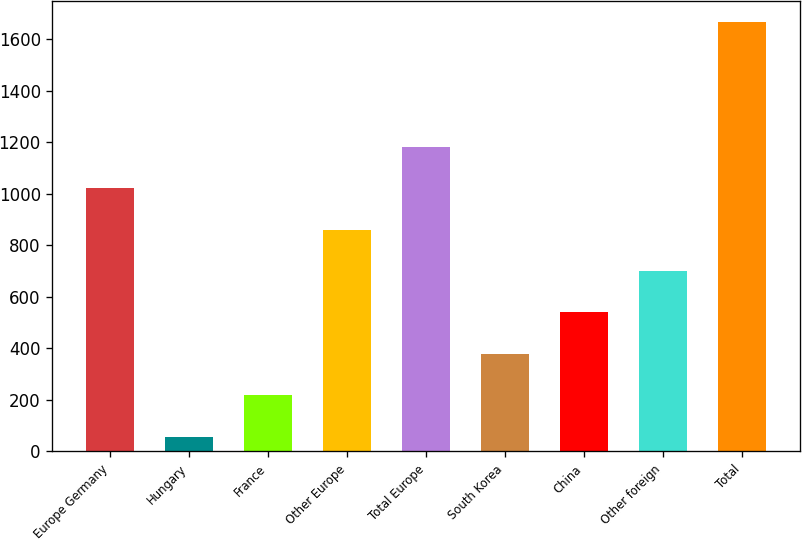<chart> <loc_0><loc_0><loc_500><loc_500><bar_chart><fcel>Europe Germany<fcel>Hungary<fcel>France<fcel>Other Europe<fcel>Total Europe<fcel>South Korea<fcel>China<fcel>Other foreign<fcel>Total<nl><fcel>1021.34<fcel>56.9<fcel>217.64<fcel>860.6<fcel>1182.08<fcel>378.38<fcel>539.12<fcel>699.86<fcel>1664.3<nl></chart> 